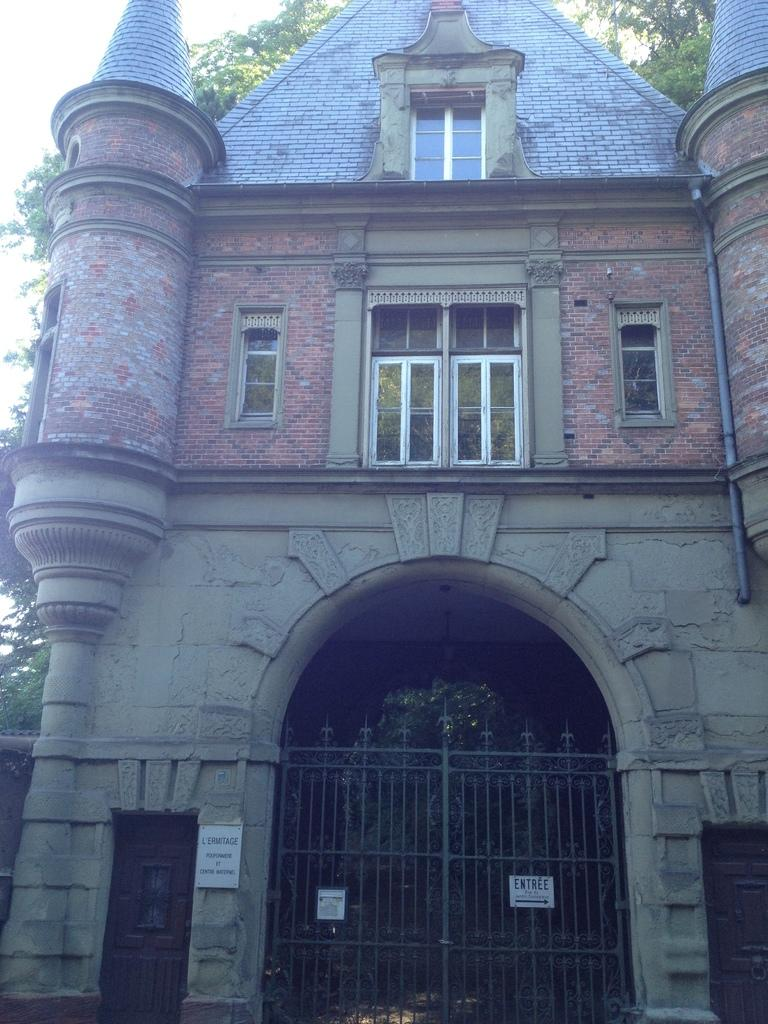What type of structure is present in the image? There is a house in the image. What features can be observed on the house? The house has windows and a gate. What is placed on the gate have on it? There are boards on the gate. What is visible behind the house? There are trees behind the house. What can be seen in the sky in the image? The sky is visible in the image. Reasoning: Let' Let's think step by step in order to produce the conversation. We start by identifying the main subject in the image, which is the house. Then, we expand the conversation to include other details about the house, such as its windows, gate, and the boards on the gate. We also mention the trees behind the house and the sky visible in the image. Each question is designed to elicit a specific detail about the image that is known from the provided facts. Absurd Question/Answer: Can you tell me how many people are swimming in the image? There is no swimming or people swimming present in the image. What type of sponge is being used to clean the windows of the house? There is no sponge or indication of cleaning the windows in the image. 